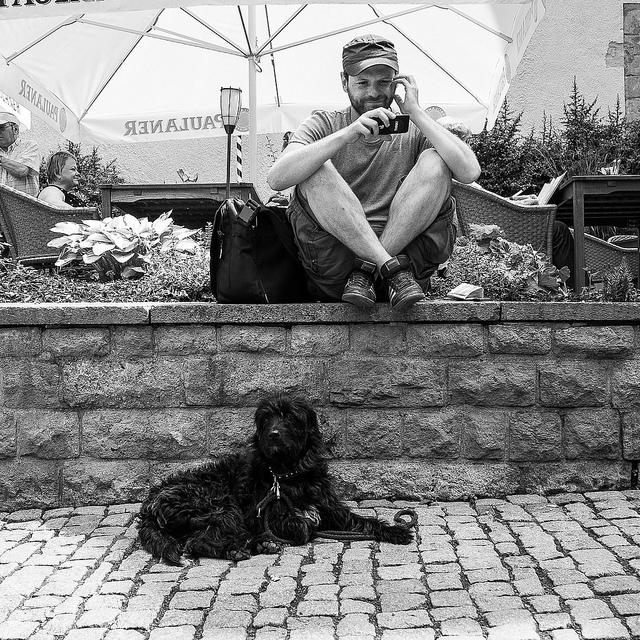Is the picture taken outside?
Short answer required. Yes. Does the dog have a collar?
Answer briefly. Yes. What is the man sitting under?
Answer briefly. Umbrella. 